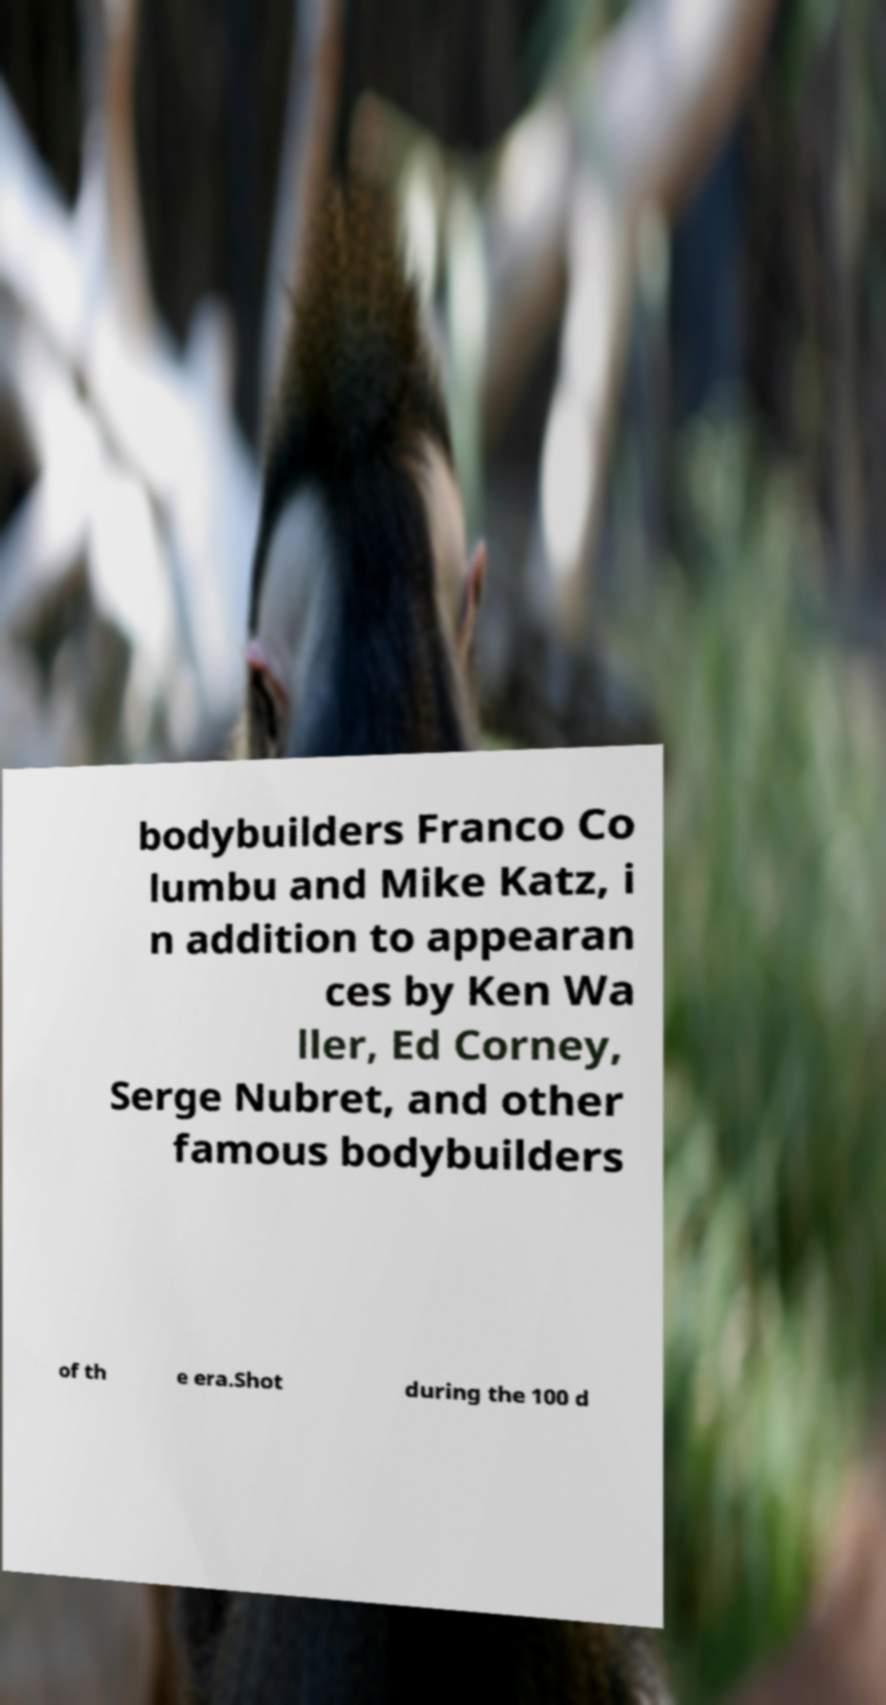Could you extract and type out the text from this image? bodybuilders Franco Co lumbu and Mike Katz, i n addition to appearan ces by Ken Wa ller, Ed Corney, Serge Nubret, and other famous bodybuilders of th e era.Shot during the 100 d 